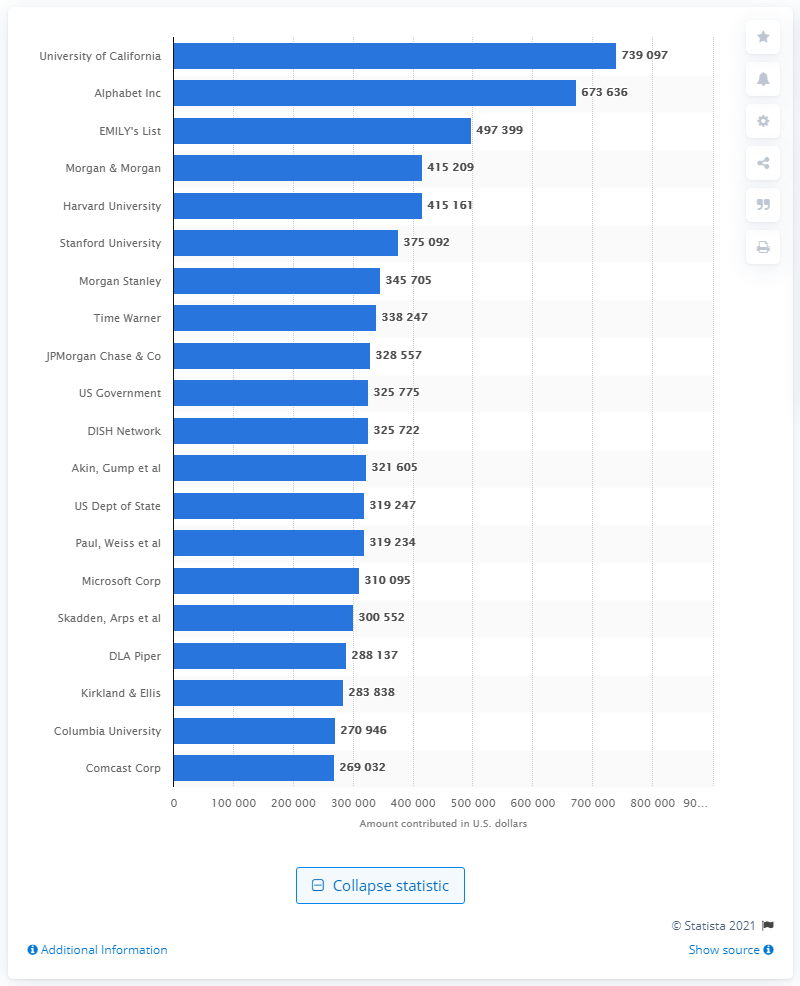Draw attention to some important aspects in this diagram. The University of California contributed approximately 739,097 dollars to Hillary Clinton's presidential campaign. 